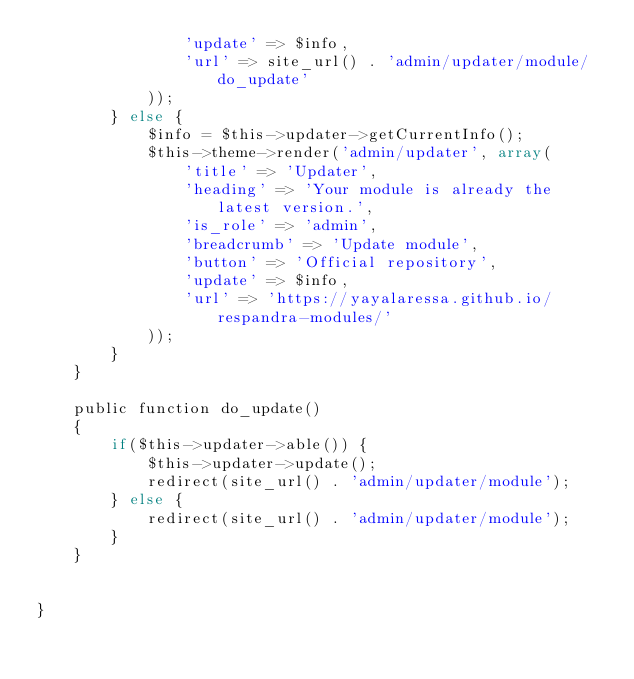Convert code to text. <code><loc_0><loc_0><loc_500><loc_500><_PHP_>                'update' => $info,
                'url' => site_url() . 'admin/updater/module/do_update'
            ));
        } else {
            $info = $this->updater->getCurrentInfo();
            $this->theme->render('admin/updater', array(
                'title' => 'Updater',
                'heading' => 'Your module is already the latest version.',
                'is_role' => 'admin',
                'breadcrumb' => 'Update module',
                'button' => 'Official repository',
                'update' => $info,
                'url' => 'https://yayalaressa.github.io/respandra-modules/'
            ));
        }   
    }

    public function do_update()
    {
        if($this->updater->able()) {
            $this->updater->update();
            redirect(site_url() . 'admin/updater/module');
        } else {
            redirect(site_url() . 'admin/updater/module');
        }
    }


}

</code> 